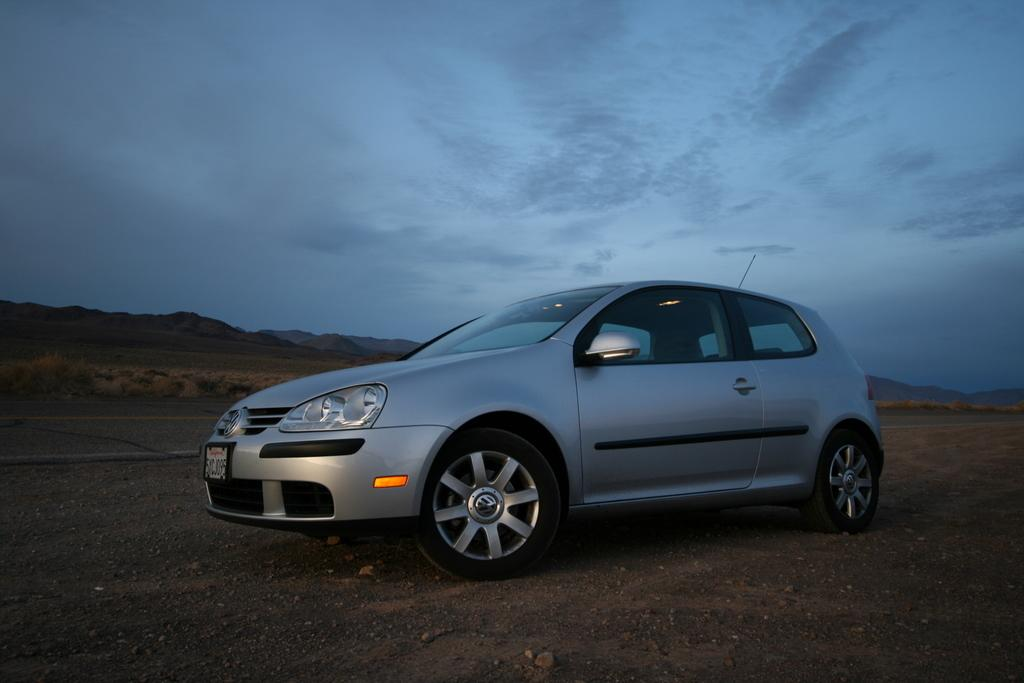What is the main subject of the image? There is a car in the image. What can be seen in the background of the image? There is grass in the background of the image. What type of natural features are visible in the image? Mountains are visible in the image. What is visible in the sky at the top of the image? Clouds are present in the sky at the top of the image. What type of thought is being expressed by the car in the image? Cars do not have the ability to express thoughts, so this question cannot be answered. 